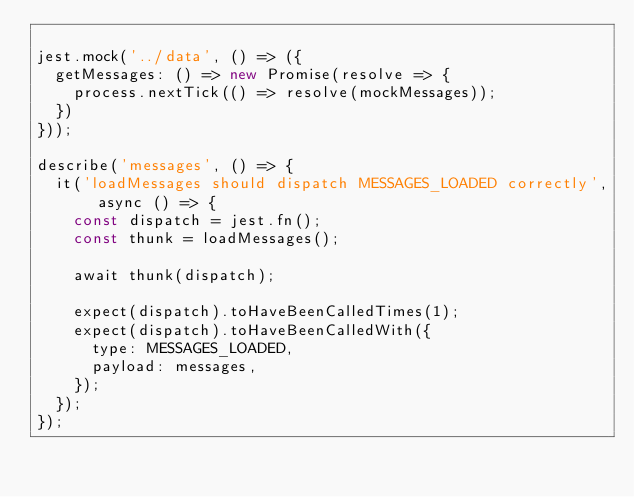Convert code to text. <code><loc_0><loc_0><loc_500><loc_500><_JavaScript_>
jest.mock('../data', () => ({
  getMessages: () => new Promise(resolve => {
    process.nextTick(() => resolve(mockMessages));
  })
}));

describe('messages', () => {
  it('loadMessages should dispatch MESSAGES_LOADED correctly', async () => {
    const dispatch = jest.fn();
    const thunk = loadMessages();

    await thunk(dispatch);

    expect(dispatch).toHaveBeenCalledTimes(1);
    expect(dispatch).toHaveBeenCalledWith({
      type: MESSAGES_LOADED,
      payload: messages,
    });
  });
});
</code> 